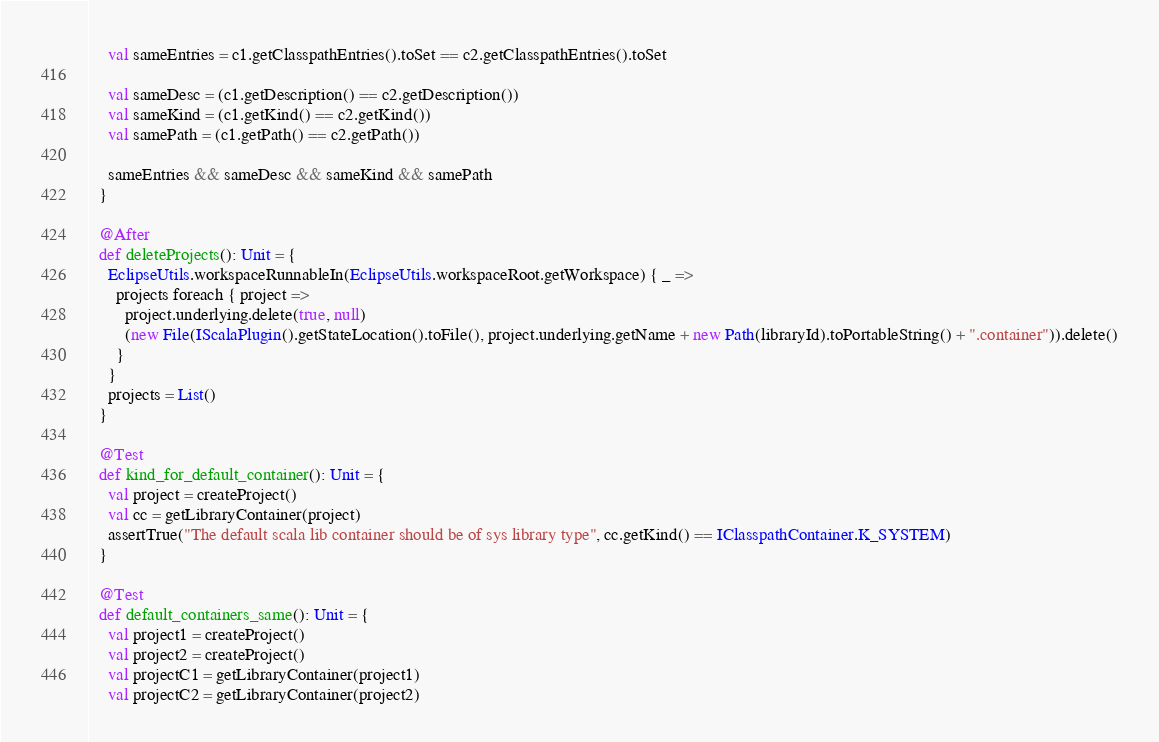Convert code to text. <code><loc_0><loc_0><loc_500><loc_500><_Scala_>    val sameEntries = c1.getClasspathEntries().toSet == c2.getClasspathEntries().toSet

    val sameDesc = (c1.getDescription() == c2.getDescription())
    val sameKind = (c1.getKind() == c2.getKind())
    val samePath = (c1.getPath() == c2.getPath())

    sameEntries && sameDesc && sameKind && samePath
  }

  @After
  def deleteProjects(): Unit = {
    EclipseUtils.workspaceRunnableIn(EclipseUtils.workspaceRoot.getWorkspace) { _ =>
      projects foreach { project =>
        project.underlying.delete(true, null)
        (new File(IScalaPlugin().getStateLocation().toFile(), project.underlying.getName + new Path(libraryId).toPortableString() + ".container")).delete()
      }
    }
    projects = List()
  }

  @Test
  def kind_for_default_container(): Unit = {
    val project = createProject()
    val cc = getLibraryContainer(project)
    assertTrue("The default scala lib container should be of sys library type", cc.getKind() == IClasspathContainer.K_SYSTEM)
  }

  @Test
  def default_containers_same(): Unit = {
    val project1 = createProject()
    val project2 = createProject()
    val projectC1 = getLibraryContainer(project1)
    val projectC2 = getLibraryContainer(project2)</code> 